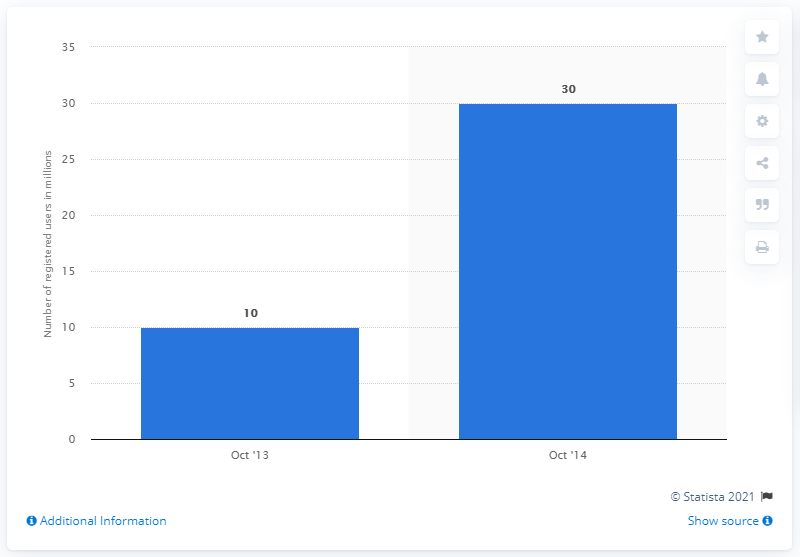Highlight a few significant elements in this photo. In October 2014, LINE had approximately 30 registered users. 